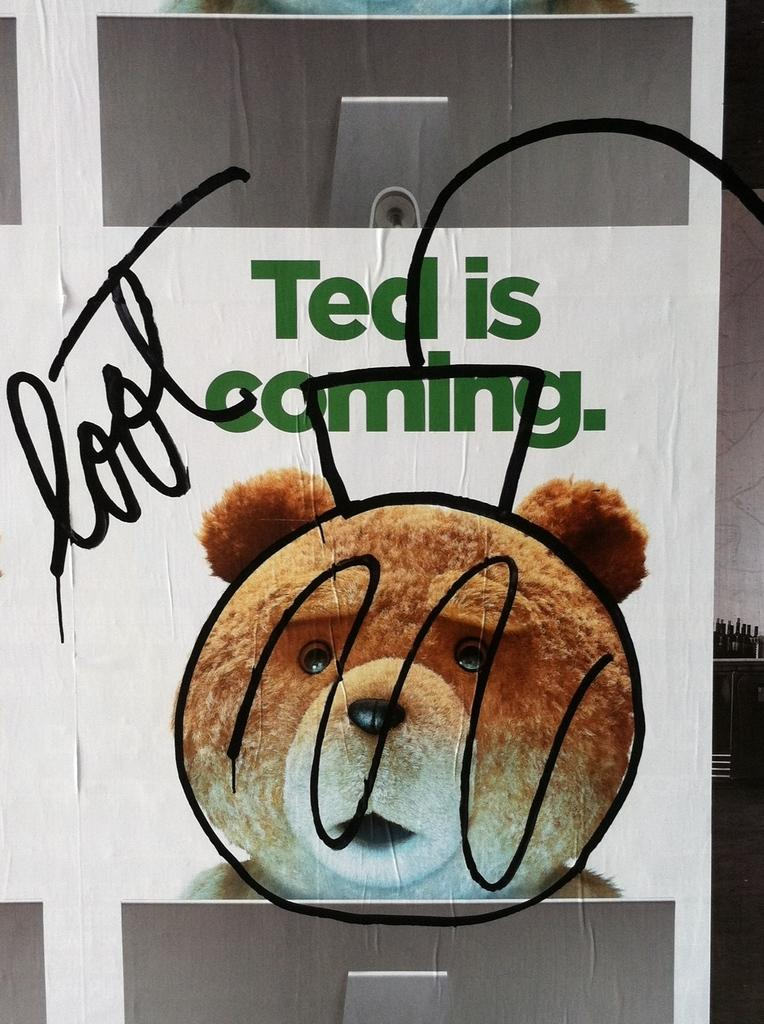What is featured on the poster in the image? The poster contains an image of a teddy bear. What else can be seen on the poster besides the image? There is text on the poster. What type of wax can be seen melting on the teddy bear's mouth in the image? There is no wax or mouth present on the teddy bear in the image, as it is a two-dimensional representation on a poster. 